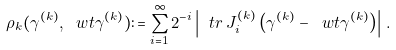Convert formula to latex. <formula><loc_0><loc_0><loc_500><loc_500>\rho _ { k } ( \gamma ^ { ( k ) } , \ w t \gamma ^ { ( k ) } ) \colon = \sum _ { i = 1 } ^ { \infty } 2 ^ { - i } \left | \ t r \, J ^ { ( k ) } _ { i } \left ( \gamma ^ { ( k ) } - \ w t \gamma ^ { ( k ) } \right ) \right | \, .</formula> 